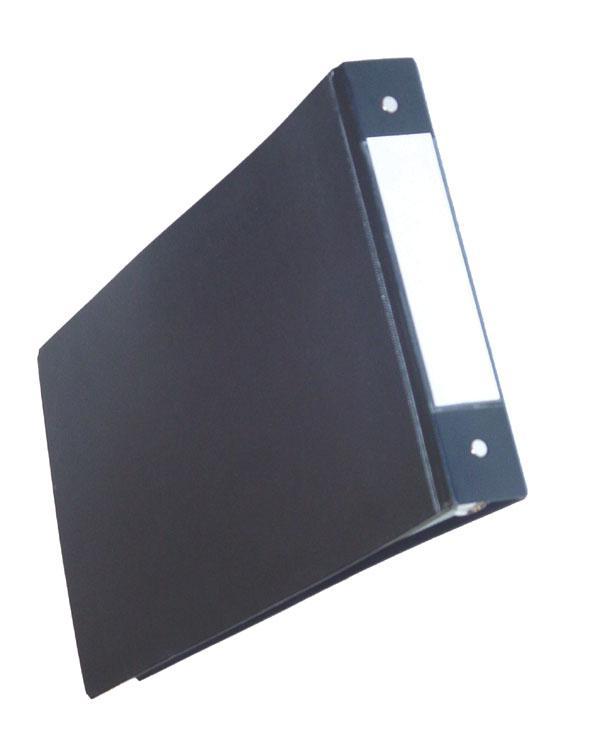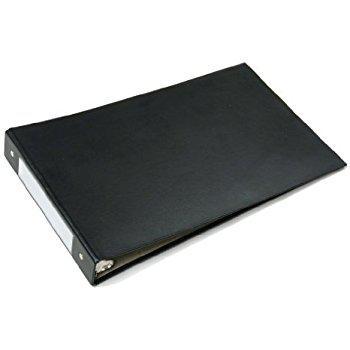The first image is the image on the left, the second image is the image on the right. Evaluate the accuracy of this statement regarding the images: "The binder in the image on the right is open to show white pages.". Is it true? Answer yes or no. No. The first image is the image on the left, the second image is the image on the right. For the images displayed, is the sentence "One image shows a single upright black binder, and the other image shows a paper-filled open binder lying by at least one upright closed binder." factually correct? Answer yes or no. No. 